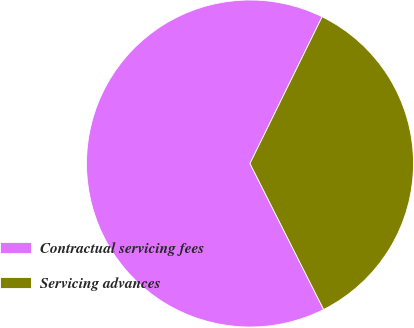<chart> <loc_0><loc_0><loc_500><loc_500><pie_chart><fcel>Contractual servicing fees<fcel>Servicing advances<nl><fcel>64.71%<fcel>35.29%<nl></chart> 